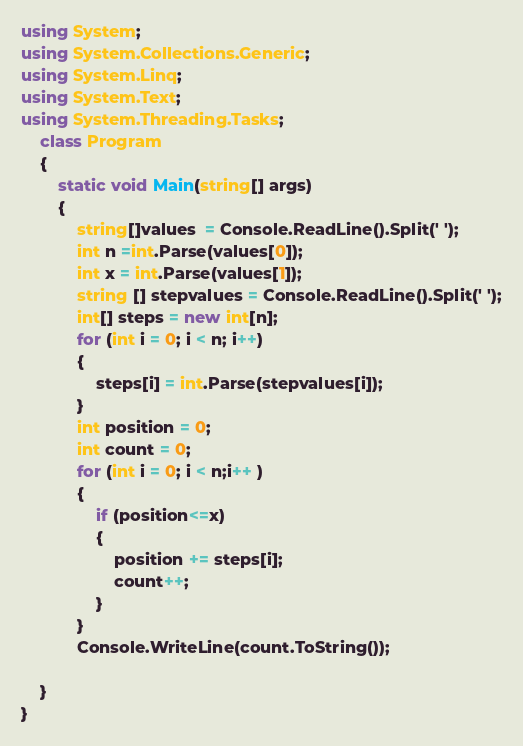Convert code to text. <code><loc_0><loc_0><loc_500><loc_500><_C#_>using System;
using System.Collections.Generic;
using System.Linq;
using System.Text;
using System.Threading.Tasks;
	class Program
	{
		static void Main(string[] args)
		{
			string[]values  = Console.ReadLine().Split(' ');
			int n =int.Parse(values[0]);
			int x = int.Parse(values[1]);
			string [] stepvalues = Console.ReadLine().Split(' ');
			int[] steps = new int[n];
			for (int i = 0; i < n; i++)
			{
				steps[i] = int.Parse(stepvalues[i]);
			}
			int position = 0;
			int count = 0;
			for (int i = 0; i < n;i++ )
			{
				if (position<=x)
				{
					position += steps[i];
					count++;
				}
			}
			Console.WriteLine(count.ToString());

	}
}
</code> 